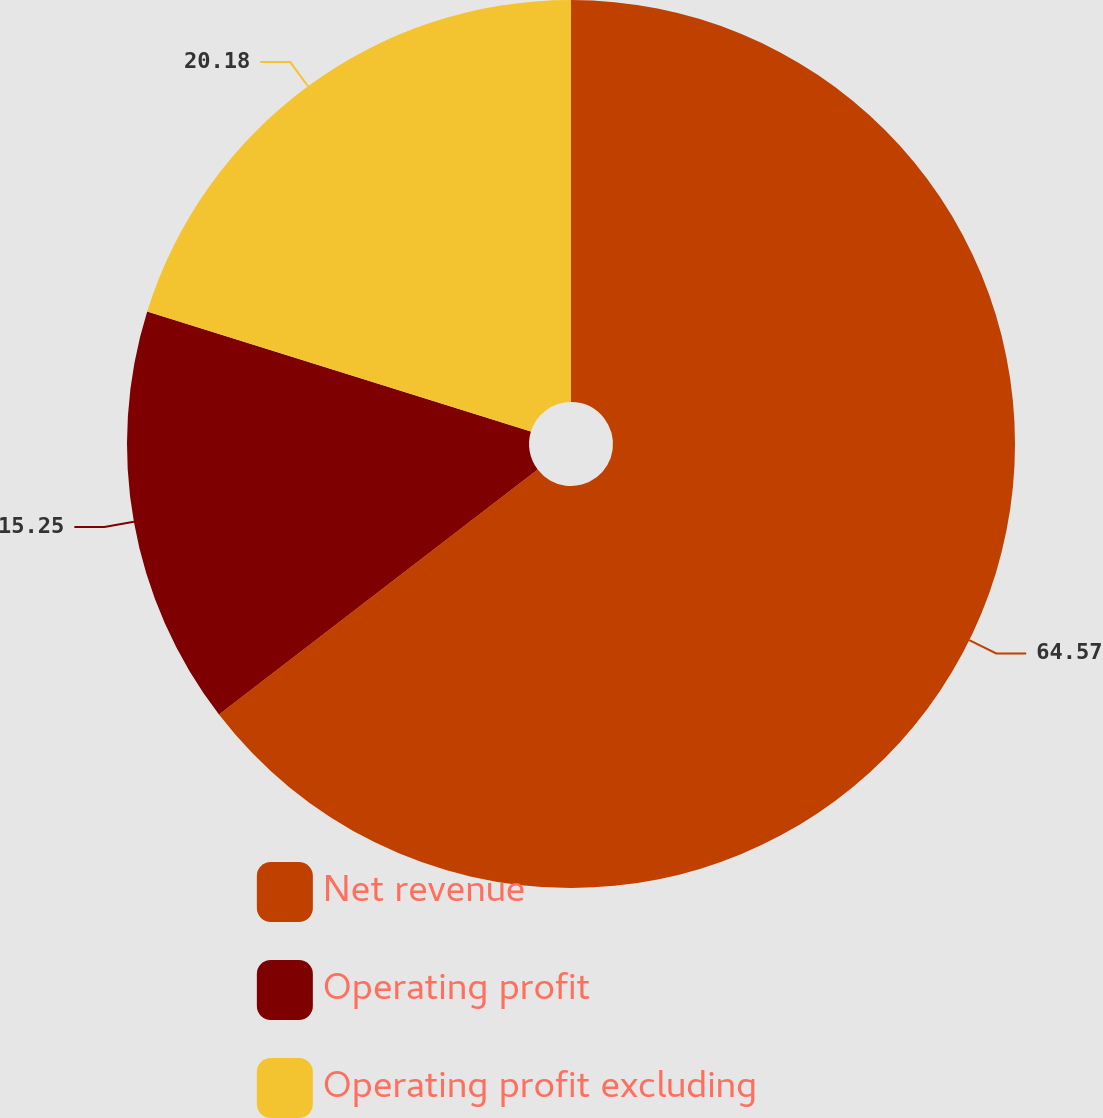Convert chart. <chart><loc_0><loc_0><loc_500><loc_500><pie_chart><fcel>Net revenue<fcel>Operating profit<fcel>Operating profit excluding<nl><fcel>64.57%<fcel>15.25%<fcel>20.18%<nl></chart> 